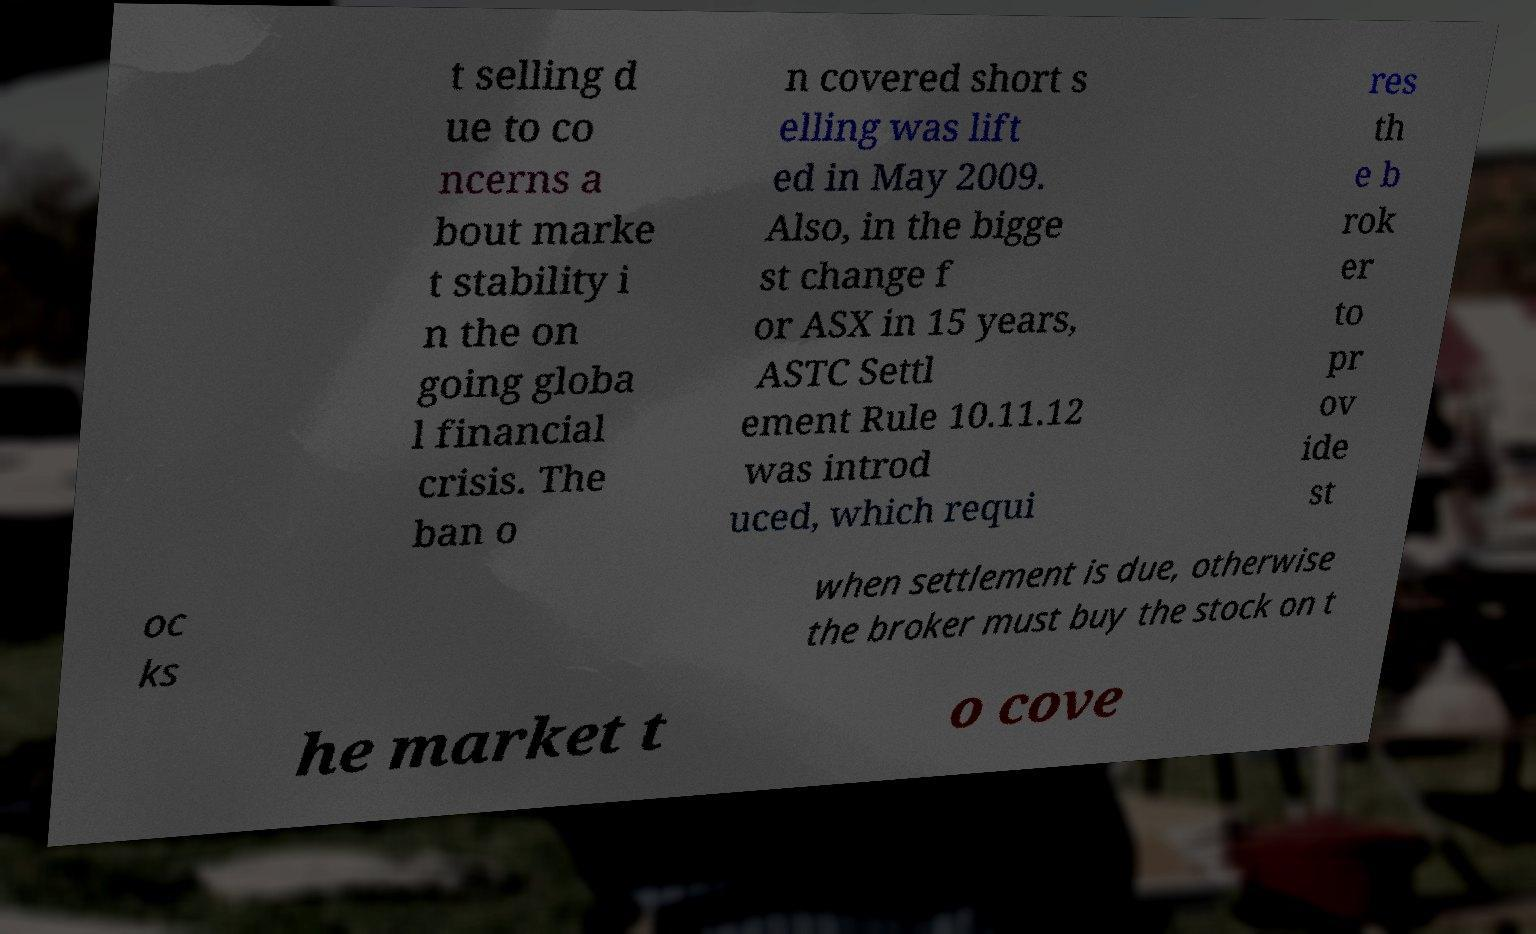Please read and relay the text visible in this image. What does it say? t selling d ue to co ncerns a bout marke t stability i n the on going globa l financial crisis. The ban o n covered short s elling was lift ed in May 2009. Also, in the bigge st change f or ASX in 15 years, ASTC Settl ement Rule 10.11.12 was introd uced, which requi res th e b rok er to pr ov ide st oc ks when settlement is due, otherwise the broker must buy the stock on t he market t o cove 